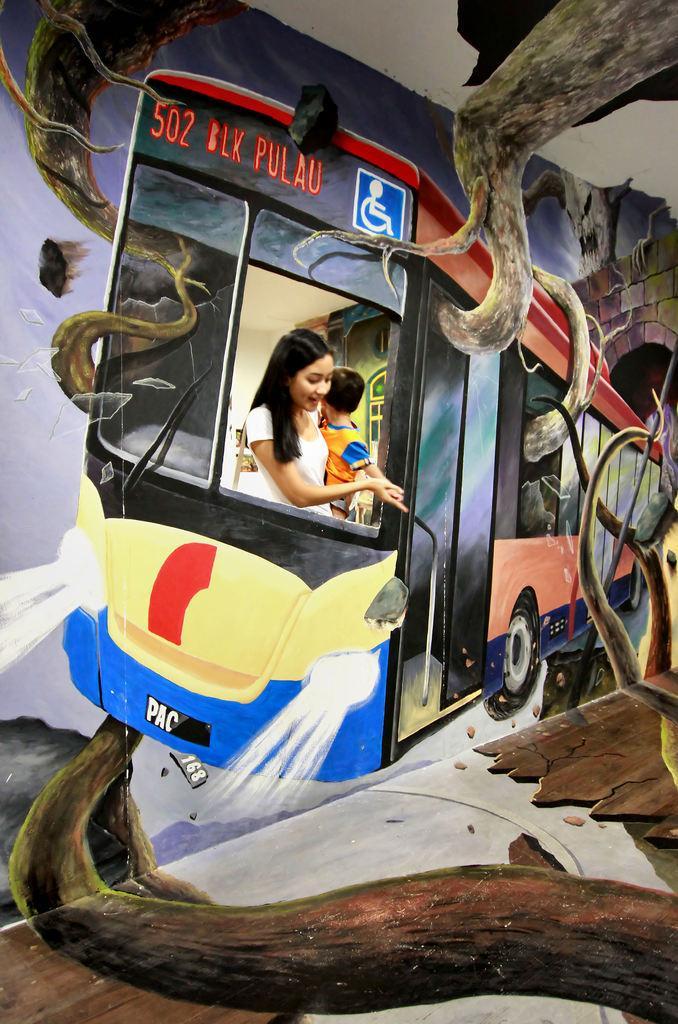Could you give a brief overview of what you see in this image? In this picture we can see art design on the wall. In the front we can see the bus painting art on the wall and a woman with a small boy standing at the bus window. 